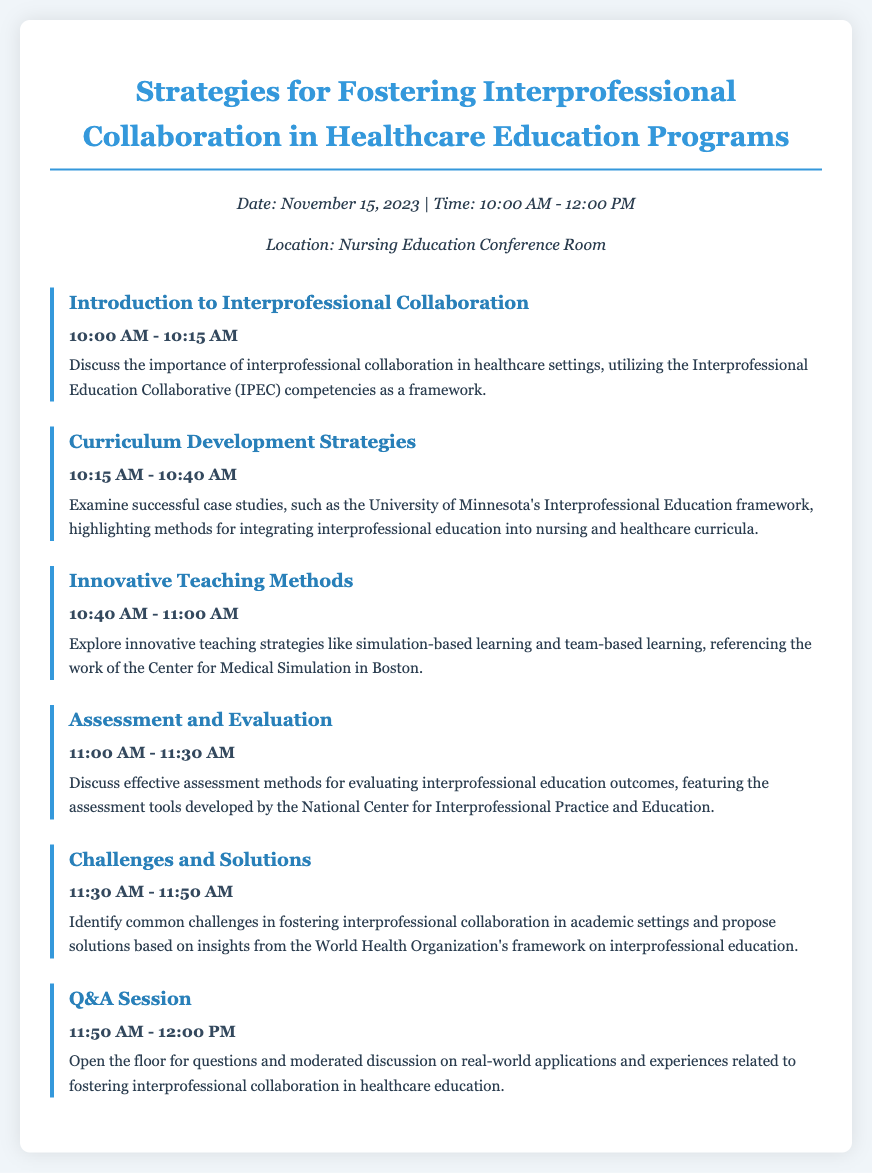What is the date of the event? The date is specified in the document as November 15, 2023.
Answer: November 15, 2023 What time does the Q&A session start? The time for the Q&A session is listed in the agenda as 11:50 AM to 12:00 PM.
Answer: 11:50 AM What topic is covered from 10:15 AM to 10:40 AM? The agenda item during this time is titled "Curriculum Development Strategies."
Answer: Curriculum Development Strategies Which educational framework is referenced in the introduction? The introduction discusses the Interprofessional Education Collaborative (IPEC) competencies.
Answer: IPEC competencies What common theme is addressed in the section titled "Challenges and Solutions"? The section addresses common challenges in fostering interprofessional collaboration in academic settings.
Answer: Common challenges What is the purpose of the "Assessment and Evaluation" topic? The purpose is to discuss effective assessment methods for evaluating interprofessional education outcomes.
Answer: Effective assessment methods 